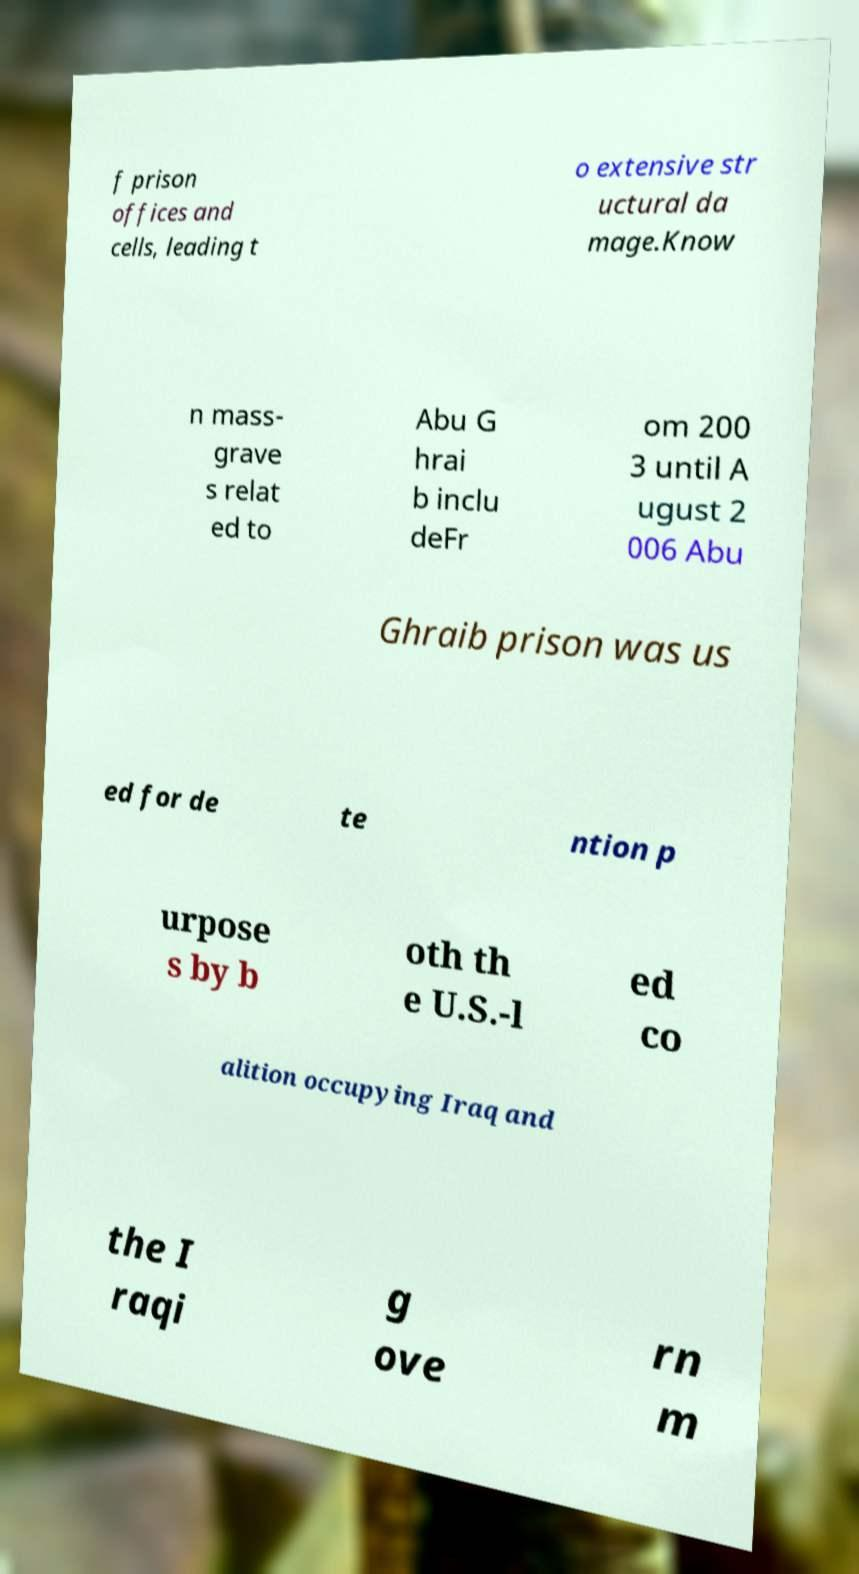Could you assist in decoding the text presented in this image and type it out clearly? f prison offices and cells, leading t o extensive str uctural da mage.Know n mass- grave s relat ed to Abu G hrai b inclu deFr om 200 3 until A ugust 2 006 Abu Ghraib prison was us ed for de te ntion p urpose s by b oth th e U.S.-l ed co alition occupying Iraq and the I raqi g ove rn m 